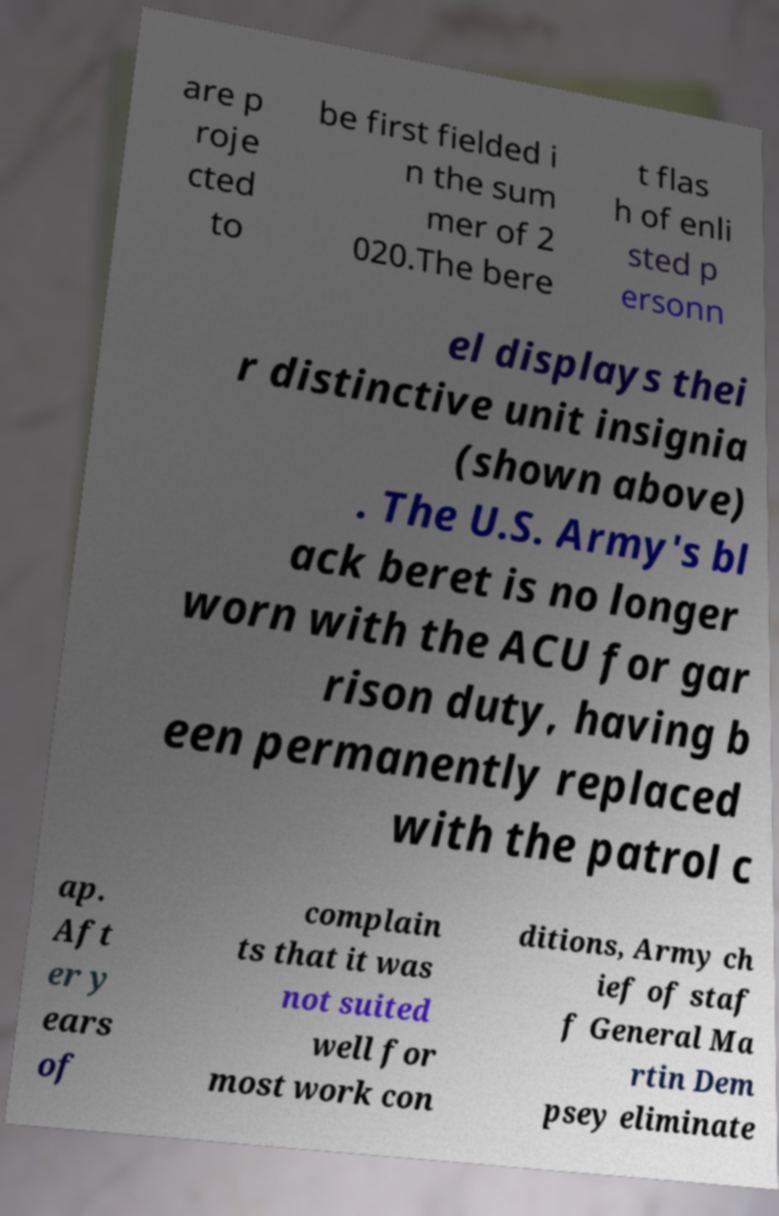There's text embedded in this image that I need extracted. Can you transcribe it verbatim? are p roje cted to be first fielded i n the sum mer of 2 020.The bere t flas h of enli sted p ersonn el displays thei r distinctive unit insignia (shown above) . The U.S. Army's bl ack beret is no longer worn with the ACU for gar rison duty, having b een permanently replaced with the patrol c ap. Aft er y ears of complain ts that it was not suited well for most work con ditions, Army ch ief of staf f General Ma rtin Dem psey eliminate 